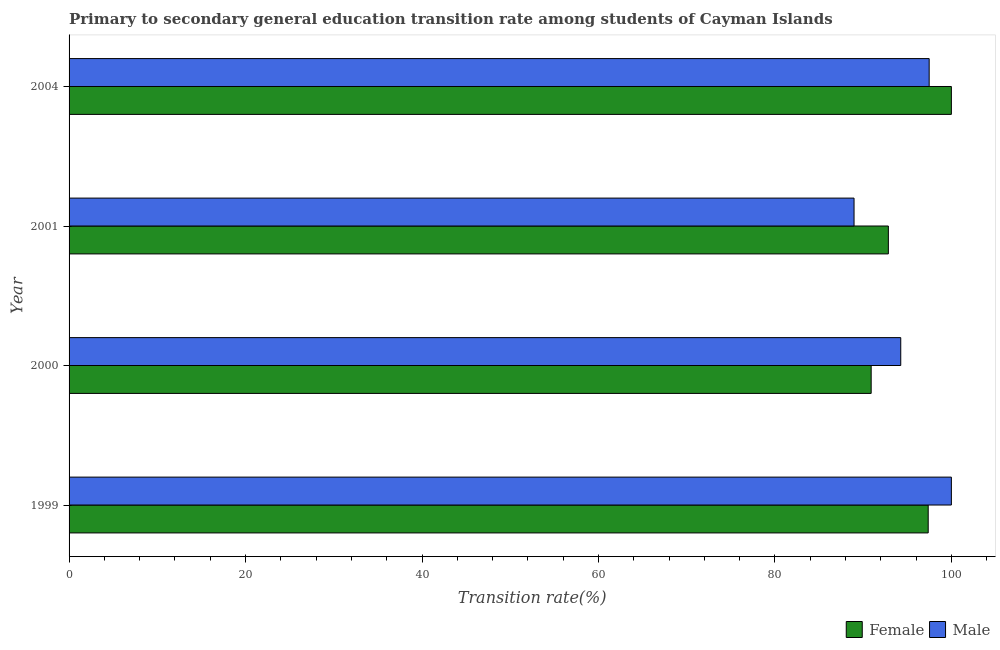How many different coloured bars are there?
Give a very brief answer. 2. How many groups of bars are there?
Give a very brief answer. 4. Are the number of bars per tick equal to the number of legend labels?
Your answer should be compact. Yes. Are the number of bars on each tick of the Y-axis equal?
Provide a succinct answer. Yes. How many bars are there on the 1st tick from the bottom?
Provide a short and direct response. 2. What is the label of the 3rd group of bars from the top?
Ensure brevity in your answer.  2000. What is the transition rate among male students in 2001?
Ensure brevity in your answer.  88.97. Across all years, what is the minimum transition rate among female students?
Your answer should be compact. 90.91. In which year was the transition rate among male students maximum?
Offer a very short reply. 1999. What is the total transition rate among male students in the graph?
Give a very brief answer. 380.71. What is the difference between the transition rate among female students in 1999 and that in 2001?
Your answer should be compact. 4.52. What is the difference between the transition rate among female students in 1999 and the transition rate among male students in 2004?
Provide a succinct answer. -0.11. What is the average transition rate among female students per year?
Offer a terse response. 95.28. In the year 1999, what is the difference between the transition rate among male students and transition rate among female students?
Give a very brief answer. 2.63. In how many years, is the transition rate among female students greater than 32 %?
Make the answer very short. 4. Is the transition rate among female students in 1999 less than that in 2004?
Your answer should be compact. Yes. Is the difference between the transition rate among female students in 1999 and 2000 greater than the difference between the transition rate among male students in 1999 and 2000?
Your answer should be very brief. Yes. What is the difference between the highest and the second highest transition rate among male students?
Keep it short and to the point. 2.52. What is the difference between the highest and the lowest transition rate among female students?
Your answer should be compact. 9.09. Is the sum of the transition rate among female students in 1999 and 2004 greater than the maximum transition rate among male students across all years?
Offer a terse response. Yes. What does the 2nd bar from the top in 2004 represents?
Offer a terse response. Female. How many bars are there?
Keep it short and to the point. 8. How many years are there in the graph?
Your response must be concise. 4. What is the difference between two consecutive major ticks on the X-axis?
Ensure brevity in your answer.  20. Does the graph contain any zero values?
Keep it short and to the point. No. How are the legend labels stacked?
Your answer should be compact. Horizontal. What is the title of the graph?
Provide a succinct answer. Primary to secondary general education transition rate among students of Cayman Islands. What is the label or title of the X-axis?
Provide a short and direct response. Transition rate(%). What is the label or title of the Y-axis?
Offer a terse response. Year. What is the Transition rate(%) in Female in 1999?
Provide a short and direct response. 97.37. What is the Transition rate(%) in Female in 2000?
Give a very brief answer. 90.91. What is the Transition rate(%) in Male in 2000?
Keep it short and to the point. 94.26. What is the Transition rate(%) in Female in 2001?
Your response must be concise. 92.86. What is the Transition rate(%) in Male in 2001?
Your answer should be compact. 88.97. What is the Transition rate(%) in Female in 2004?
Keep it short and to the point. 100. What is the Transition rate(%) of Male in 2004?
Offer a terse response. 97.48. Across all years, what is the maximum Transition rate(%) of Female?
Provide a short and direct response. 100. Across all years, what is the minimum Transition rate(%) in Female?
Make the answer very short. 90.91. Across all years, what is the minimum Transition rate(%) of Male?
Offer a very short reply. 88.97. What is the total Transition rate(%) of Female in the graph?
Offer a very short reply. 381.14. What is the total Transition rate(%) of Male in the graph?
Make the answer very short. 380.71. What is the difference between the Transition rate(%) in Female in 1999 and that in 2000?
Make the answer very short. 6.46. What is the difference between the Transition rate(%) of Male in 1999 and that in 2000?
Ensure brevity in your answer.  5.74. What is the difference between the Transition rate(%) in Female in 1999 and that in 2001?
Your answer should be very brief. 4.52. What is the difference between the Transition rate(%) of Male in 1999 and that in 2001?
Ensure brevity in your answer.  11.03. What is the difference between the Transition rate(%) in Female in 1999 and that in 2004?
Provide a short and direct response. -2.63. What is the difference between the Transition rate(%) of Male in 1999 and that in 2004?
Ensure brevity in your answer.  2.52. What is the difference between the Transition rate(%) of Female in 2000 and that in 2001?
Your answer should be very brief. -1.95. What is the difference between the Transition rate(%) of Male in 2000 and that in 2001?
Offer a terse response. 5.29. What is the difference between the Transition rate(%) in Female in 2000 and that in 2004?
Keep it short and to the point. -9.09. What is the difference between the Transition rate(%) in Male in 2000 and that in 2004?
Ensure brevity in your answer.  -3.22. What is the difference between the Transition rate(%) in Female in 2001 and that in 2004?
Make the answer very short. -7.14. What is the difference between the Transition rate(%) of Male in 2001 and that in 2004?
Offer a terse response. -8.52. What is the difference between the Transition rate(%) in Female in 1999 and the Transition rate(%) in Male in 2000?
Make the answer very short. 3.11. What is the difference between the Transition rate(%) in Female in 1999 and the Transition rate(%) in Male in 2001?
Offer a terse response. 8.41. What is the difference between the Transition rate(%) in Female in 1999 and the Transition rate(%) in Male in 2004?
Provide a succinct answer. -0.11. What is the difference between the Transition rate(%) in Female in 2000 and the Transition rate(%) in Male in 2001?
Your answer should be very brief. 1.94. What is the difference between the Transition rate(%) in Female in 2000 and the Transition rate(%) in Male in 2004?
Provide a short and direct response. -6.57. What is the difference between the Transition rate(%) in Female in 2001 and the Transition rate(%) in Male in 2004?
Give a very brief answer. -4.63. What is the average Transition rate(%) of Female per year?
Give a very brief answer. 95.29. What is the average Transition rate(%) of Male per year?
Make the answer very short. 95.18. In the year 1999, what is the difference between the Transition rate(%) of Female and Transition rate(%) of Male?
Provide a succinct answer. -2.63. In the year 2000, what is the difference between the Transition rate(%) in Female and Transition rate(%) in Male?
Your answer should be compact. -3.35. In the year 2001, what is the difference between the Transition rate(%) in Female and Transition rate(%) in Male?
Your answer should be very brief. 3.89. In the year 2004, what is the difference between the Transition rate(%) of Female and Transition rate(%) of Male?
Provide a short and direct response. 2.52. What is the ratio of the Transition rate(%) of Female in 1999 to that in 2000?
Make the answer very short. 1.07. What is the ratio of the Transition rate(%) in Male in 1999 to that in 2000?
Provide a succinct answer. 1.06. What is the ratio of the Transition rate(%) of Female in 1999 to that in 2001?
Keep it short and to the point. 1.05. What is the ratio of the Transition rate(%) in Male in 1999 to that in 2001?
Make the answer very short. 1.12. What is the ratio of the Transition rate(%) in Female in 1999 to that in 2004?
Your answer should be very brief. 0.97. What is the ratio of the Transition rate(%) of Male in 1999 to that in 2004?
Give a very brief answer. 1.03. What is the ratio of the Transition rate(%) in Female in 2000 to that in 2001?
Offer a very short reply. 0.98. What is the ratio of the Transition rate(%) in Male in 2000 to that in 2001?
Keep it short and to the point. 1.06. What is the ratio of the Transition rate(%) of Female in 2001 to that in 2004?
Your response must be concise. 0.93. What is the ratio of the Transition rate(%) in Male in 2001 to that in 2004?
Offer a very short reply. 0.91. What is the difference between the highest and the second highest Transition rate(%) of Female?
Offer a terse response. 2.63. What is the difference between the highest and the second highest Transition rate(%) in Male?
Provide a succinct answer. 2.52. What is the difference between the highest and the lowest Transition rate(%) in Female?
Your response must be concise. 9.09. What is the difference between the highest and the lowest Transition rate(%) in Male?
Offer a very short reply. 11.03. 